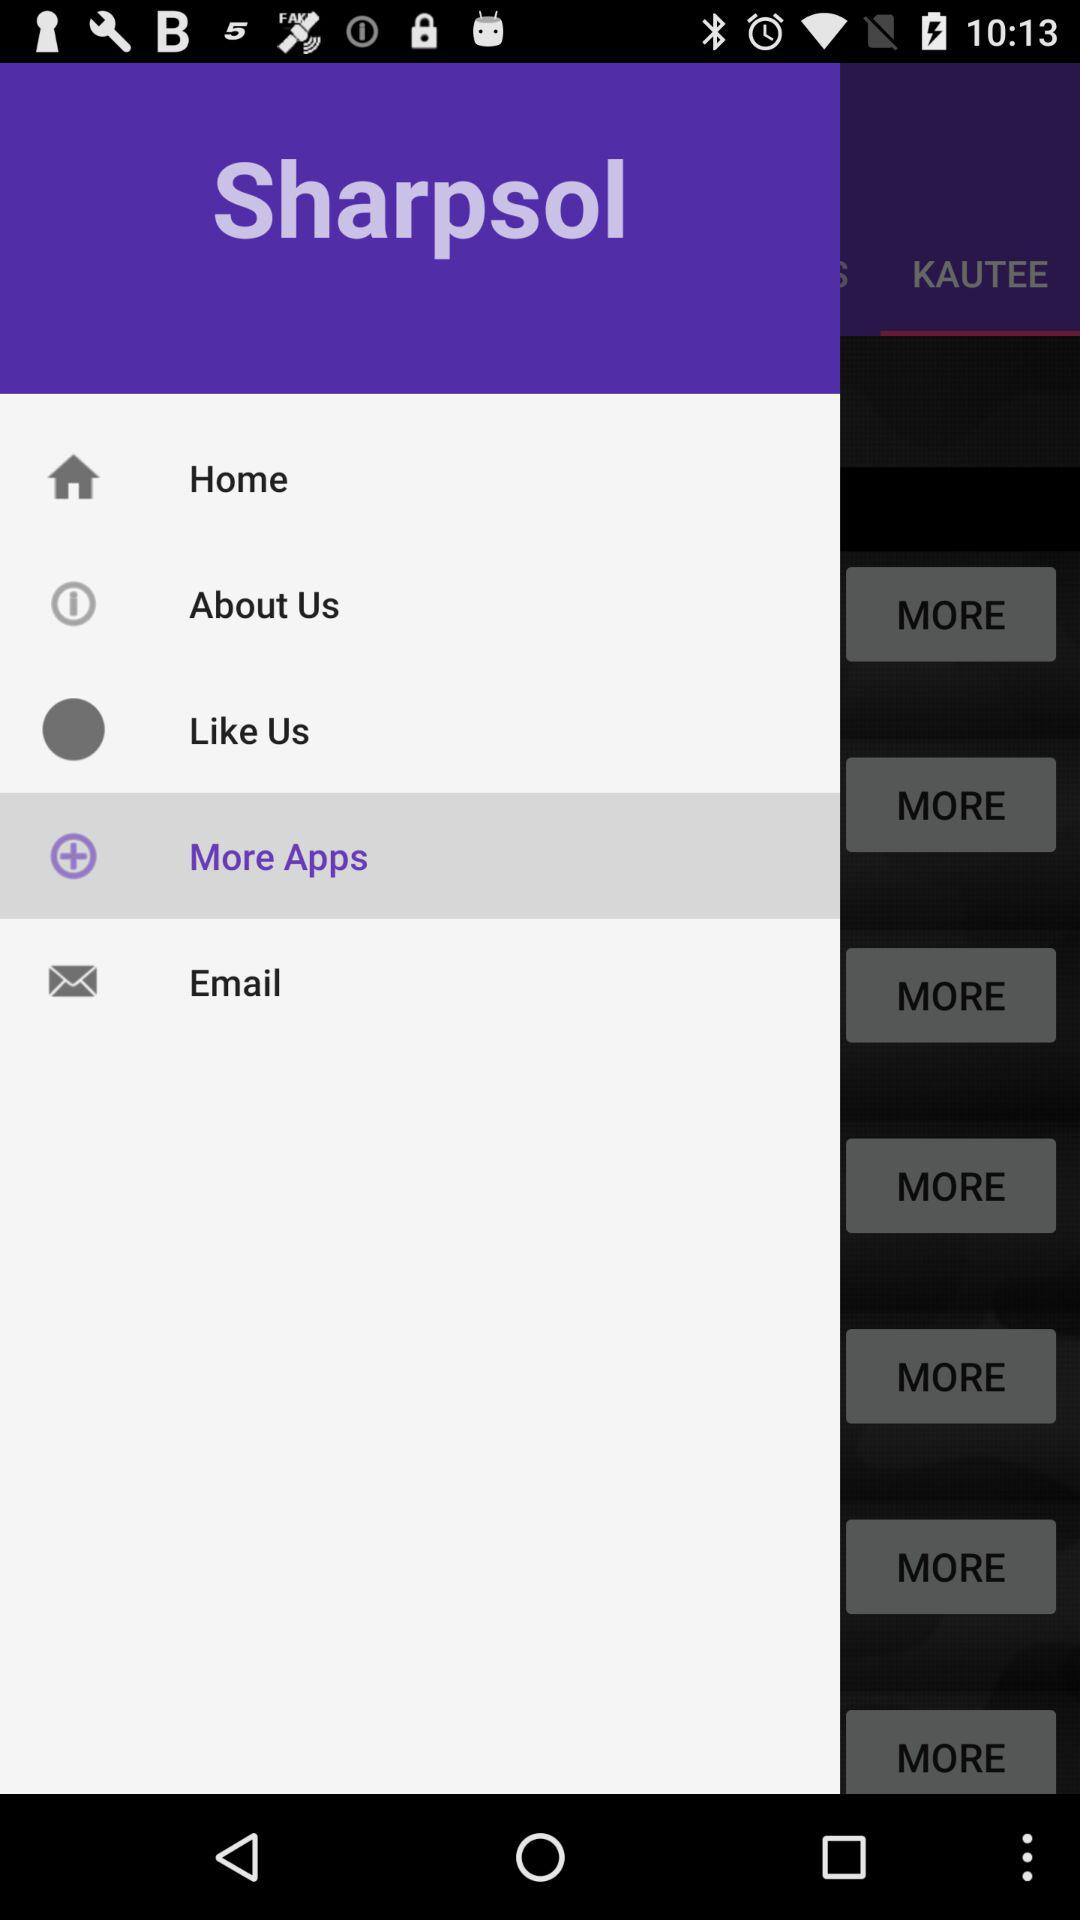What is the application name? The application name is "Sharpsol". 